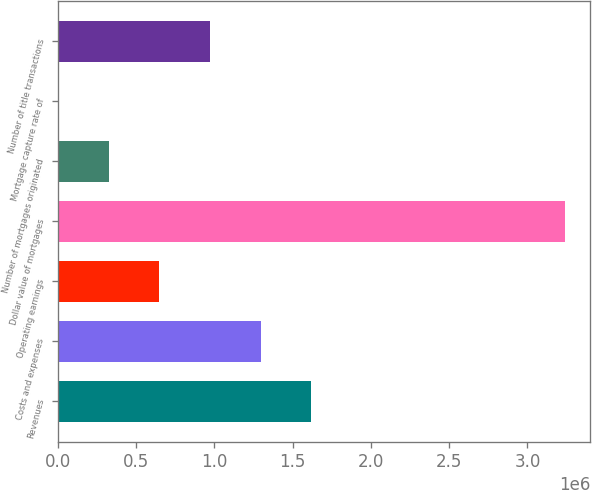<chart> <loc_0><loc_0><loc_500><loc_500><bar_chart><fcel>Revenues<fcel>Costs and expenses<fcel>Operating earnings<fcel>Dollar value of mortgages<fcel>Number of mortgages originated<fcel>Mortgage capture rate of<fcel>Number of title transactions<nl><fcel>1.62004e+06<fcel>1.29604e+06<fcel>648058<fcel>3.24e+06<fcel>324066<fcel>73<fcel>972051<nl></chart> 